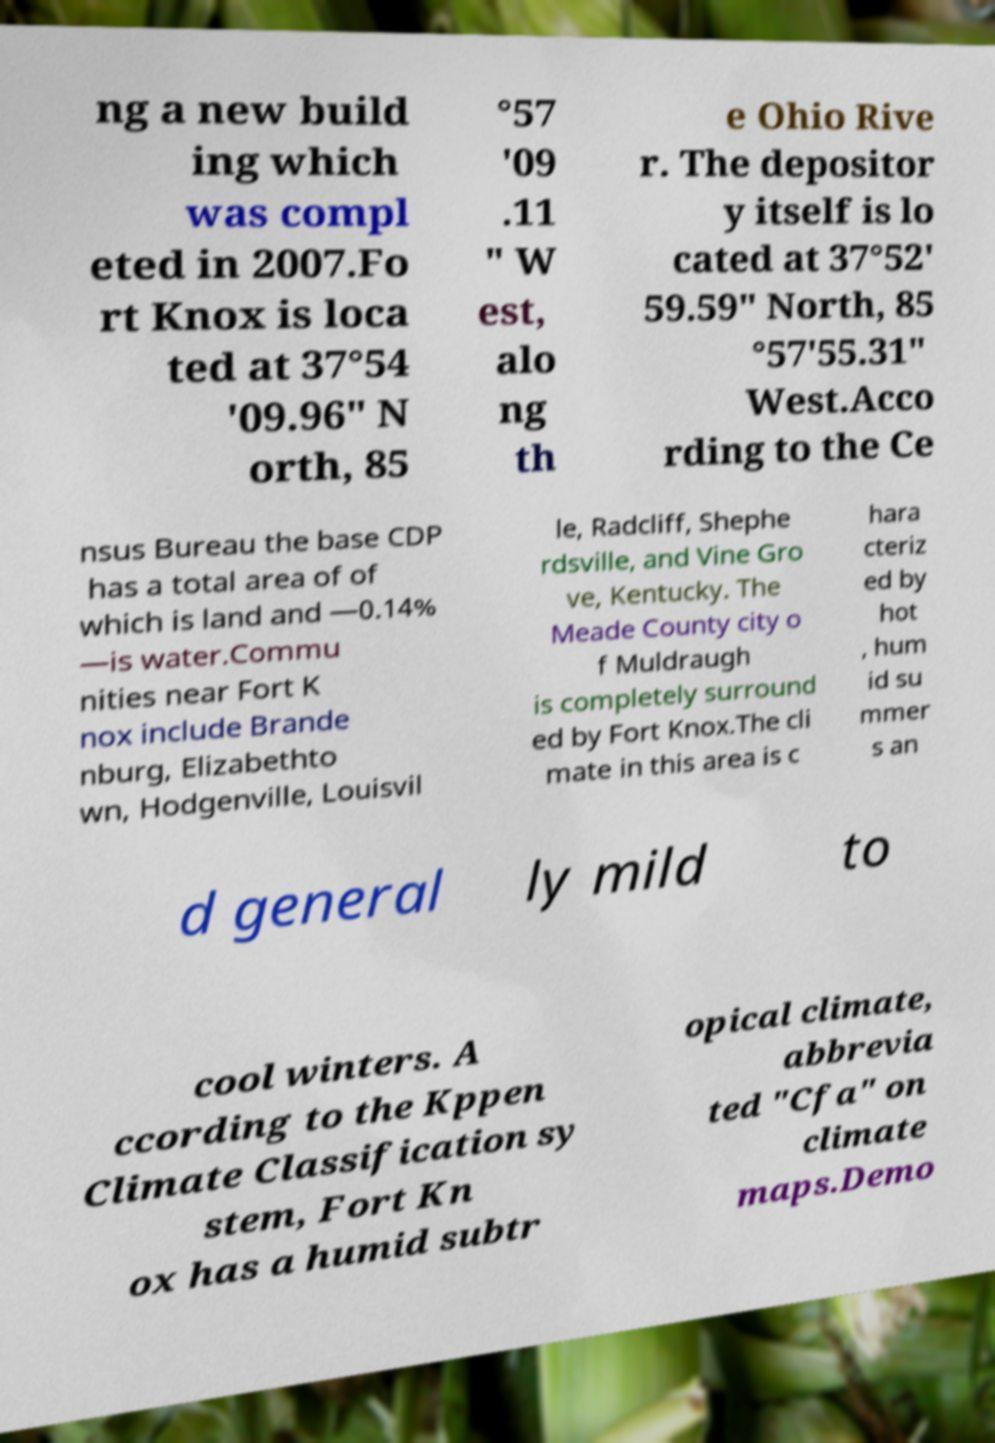For documentation purposes, I need the text within this image transcribed. Could you provide that? ng a new build ing which was compl eted in 2007.Fo rt Knox is loca ted at 37°54 '09.96" N orth, 85 °57 '09 .11 " W est, alo ng th e Ohio Rive r. The depositor y itself is lo cated at 37°52' 59.59" North, 85 °57'55.31" West.Acco rding to the Ce nsus Bureau the base CDP has a total area of of which is land and —0.14% —is water.Commu nities near Fort K nox include Brande nburg, Elizabethto wn, Hodgenville, Louisvil le, Radcliff, Shephe rdsville, and Vine Gro ve, Kentucky. The Meade County city o f Muldraugh is completely surround ed by Fort Knox.The cli mate in this area is c hara cteriz ed by hot , hum id su mmer s an d general ly mild to cool winters. A ccording to the Kppen Climate Classification sy stem, Fort Kn ox has a humid subtr opical climate, abbrevia ted "Cfa" on climate maps.Demo 